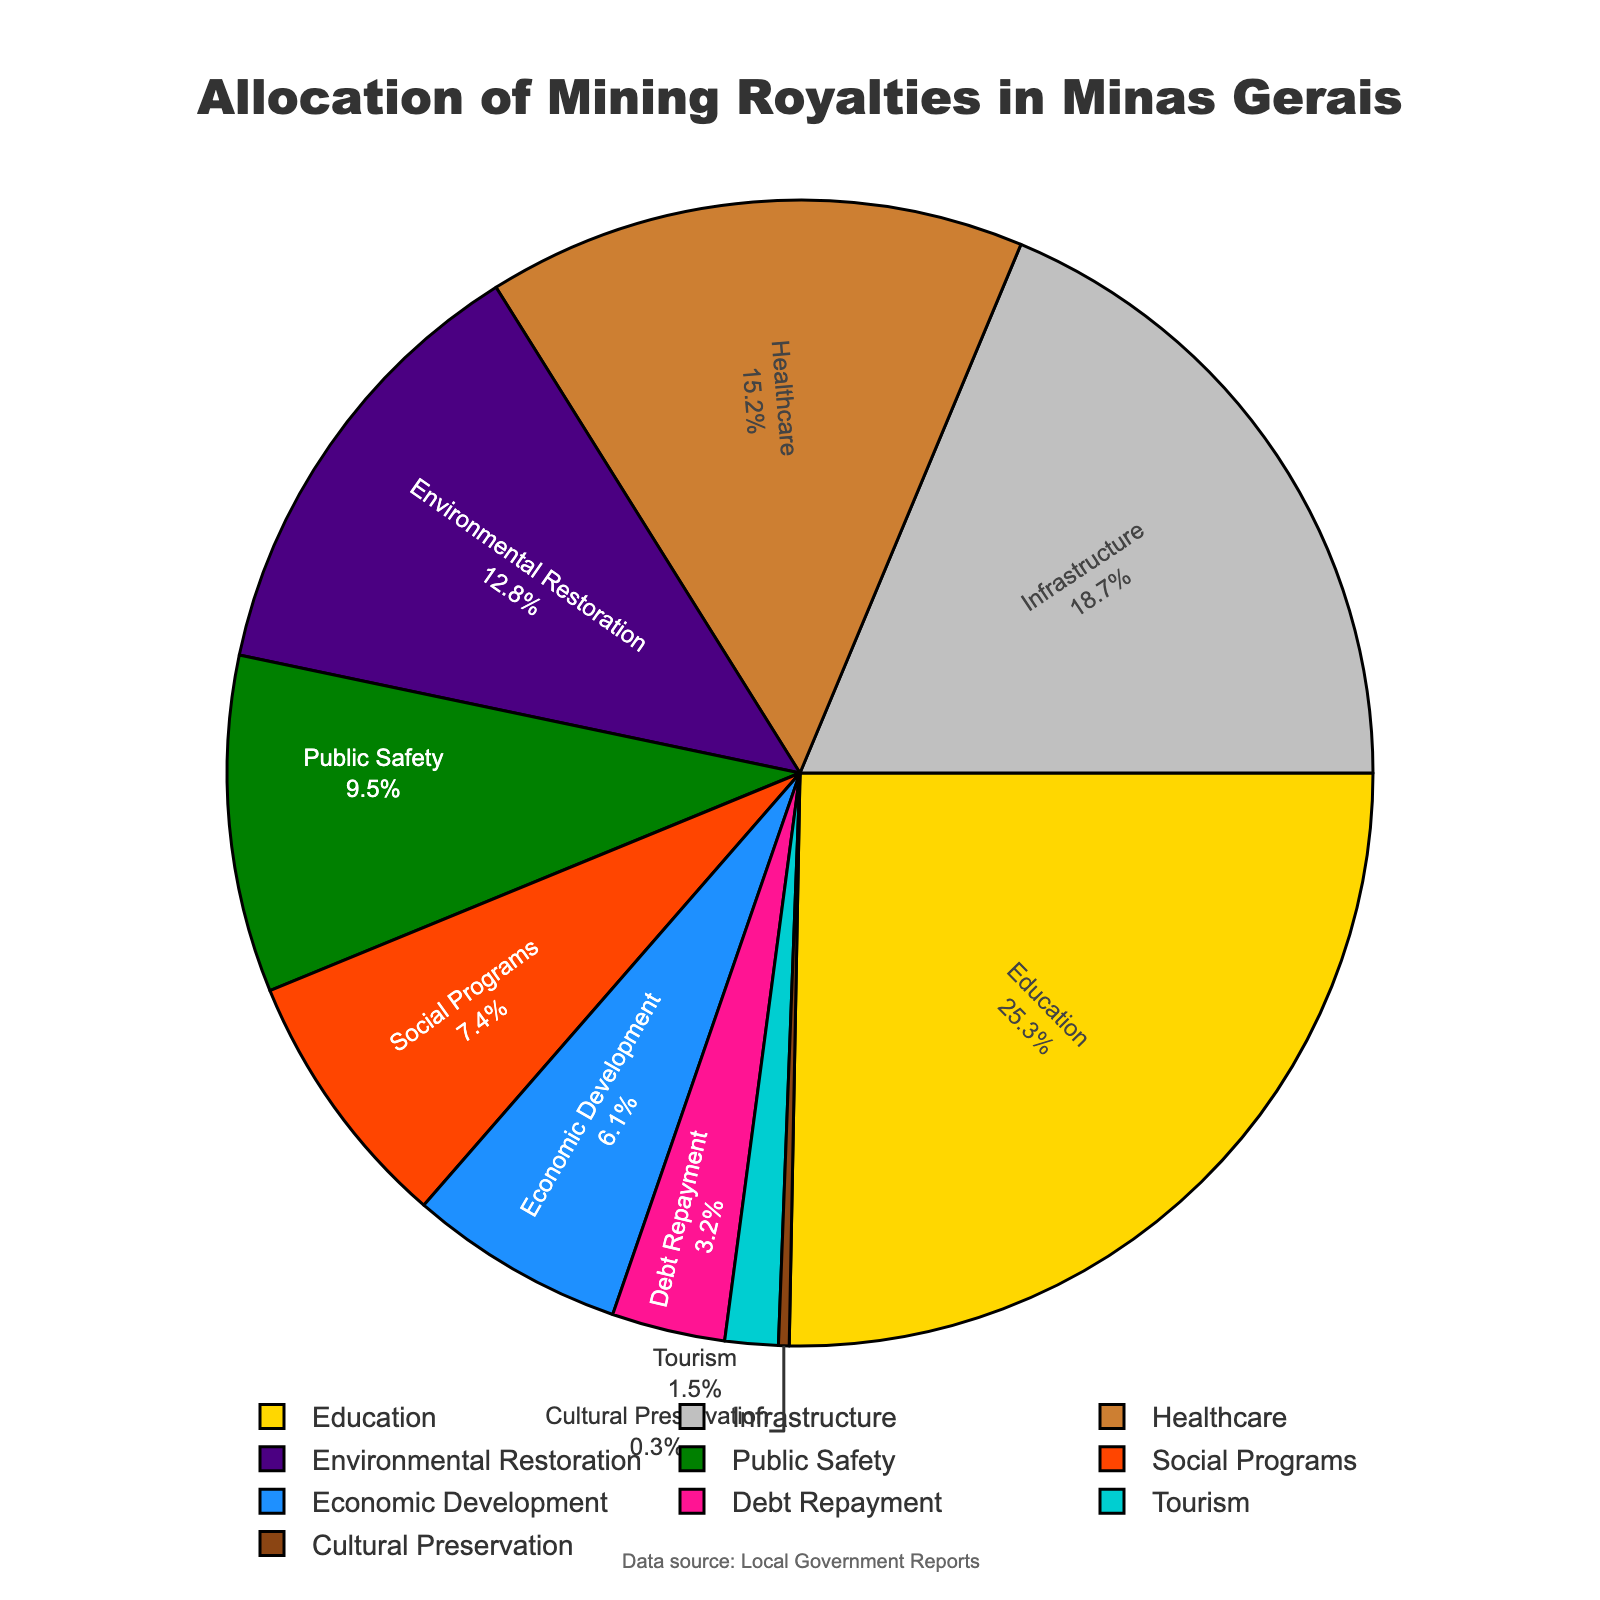What's the largest percentage allocation in the chart? The largest segment in the pie chart represents the sector with the highest allocation. This segment is "Education" and it accounts for 25.3% of the total.
Answer: Education Which sector receives the least amount of royalties? The smallest segment in the pie chart represents the sector with the lowest allocation. This segment is "Cultural Preservation" and it accounts for 0.3% of the total.
Answer: Cultural Preservation What is the combined allocation percentage for Infrastructure and Healthcare? To find the combined allocation for Infrastructure and Healthcare, sum their individual percentages: Infrastructure (18.7%) + Healthcare (15.2%) = 33.9%.
Answer: 33.9% Is more allocated to Economic Development than to Tourism? Compare the percentages for Economic Development (6.1%) and Tourism (1.5%). Economic Development has a higher allocation.
Answer: Yes What is the percentage difference between Public Safety and Social Programs? Subtract the percentage allocated to Social Programs (7.4%) from that allocated to Public Safety (9.5%): 9.5% - 7.4% = 2.1%.
Answer: 2.1% Which sector receives almost double the allocation of Debt Repayment? Look for a sector whose percentage is nearly twice that of Debt Repayment (3.2%). Healthcare (15.2%) is close, but Environmental Restoration (12.8%) is approximately four times that of Debt Repayment. Public Safety's fraction (9.5%) is also not double. Infrastructure (18.7%) is greater than double. The closest without exceeding double is Social Programs (7.4%); no exact double available.
Answer: Social Programs How do the allocations for Education and Healthcare compare in terms of percentage? Education (25.3%) is noticeably higher than Healthcare (15.2%), making Education 10.1% higher.
Answer: Education is higher by 10.1% What sectors combined give a total allocation close to the Education sector? Identify sectors whose combined percentages are close to Education’s 25.3%. Infrastructure (18.7%) + Tourism (1.5%) + Debt Repayment (3.2%) = 23.4% or Infrastructure (18.7%) + Public Safety (9.5%) is 28.2%.
Answer: Infrastructure + Debt Repayment + Tourism (23.4%) If Healthcare and Infrastructure's allocations are combined, what fraction of the total is it (in terms of the pie chart)? Sum the percentages for Healthcare (15.2%) and Infrastructure (18.7%): 33.9%. Thereby, 33.9% is the fraction they represent combined.
Answer: 33.9% 